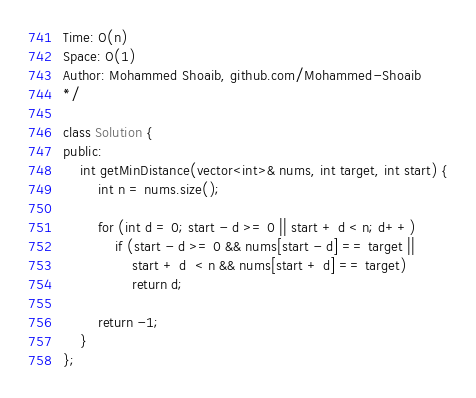<code> <loc_0><loc_0><loc_500><loc_500><_C++_>Time: O(n)
Space: O(1)
Author: Mohammed Shoaib, github.com/Mohammed-Shoaib
*/

class Solution {
public:
	int getMinDistance(vector<int>& nums, int target, int start) {
		int n = nums.size();
		
		for (int d = 0; start - d >= 0 || start + d < n; d++)
			if (start - d >= 0 && nums[start - d] == target ||
				start + d  < n && nums[start + d] == target)
				return d;
		
		return -1;
	}
};</code> 